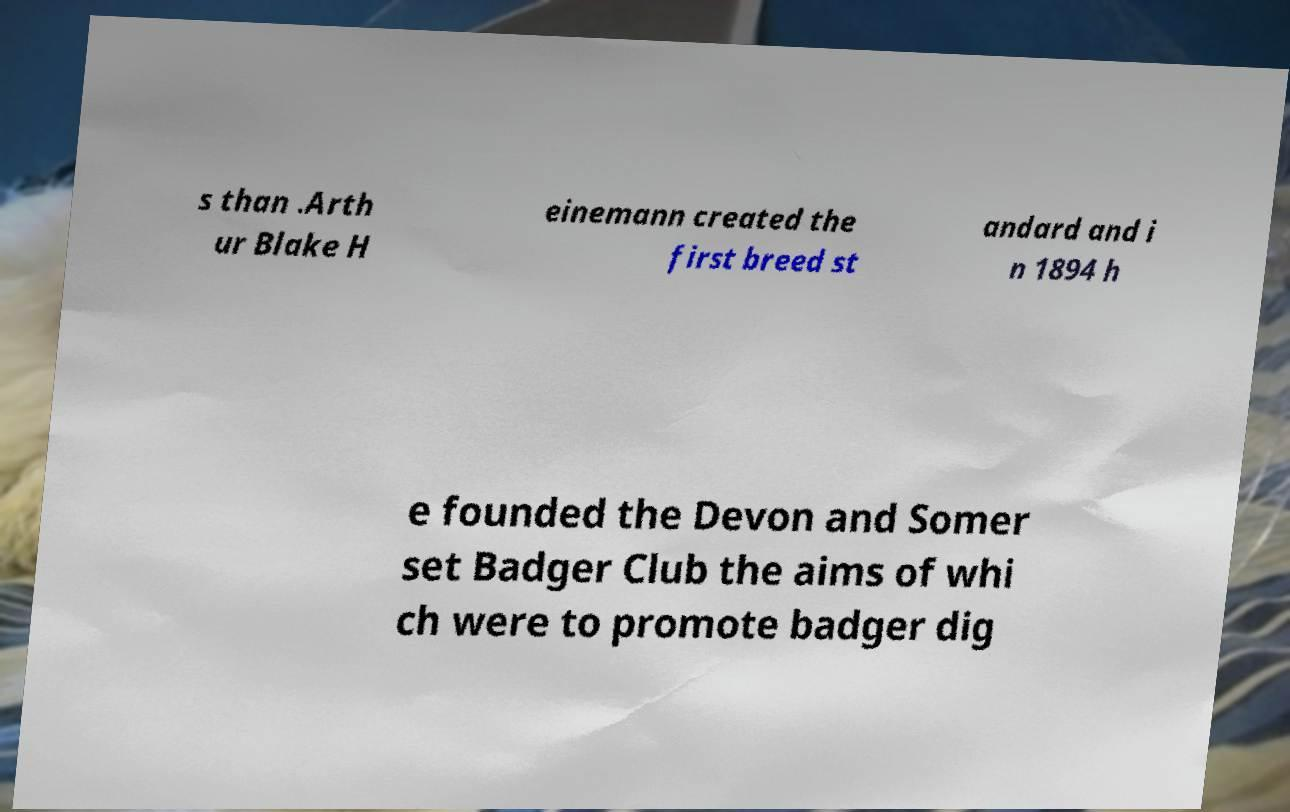I need the written content from this picture converted into text. Can you do that? s than .Arth ur Blake H einemann created the first breed st andard and i n 1894 h e founded the Devon and Somer set Badger Club the aims of whi ch were to promote badger dig 